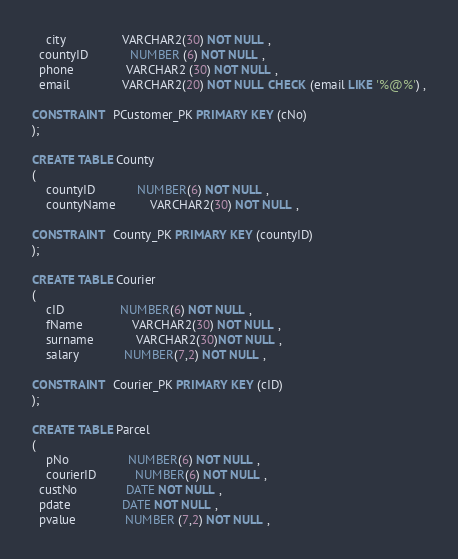<code> <loc_0><loc_0><loc_500><loc_500><_SQL_>	city                VARCHAR2(30) NOT NULL ,
  countyID            NUMBER (6) NOT NULL ,
  phone               VARCHAR2 (30) NOT NULL ,
  email               VARCHAR2(20) NOT NULL CHECK (email LIKE '%@%') ,
  
CONSTRAINT  PCustomer_PK PRIMARY KEY (cNo)
);

CREATE TABLE County
(
	countyID            NUMBER(6) NOT NULL ,
	countyName          VARCHAR2(30) NOT NULL ,
  
CONSTRAINT  County_PK PRIMARY KEY (countyID)
);

CREATE TABLE Courier
(
	cID                NUMBER(6) NOT NULL ,
	fName              VARCHAR2(30) NOT NULL ,
	surname            VARCHAR2(30)NOT NULL ,
	salary             NUMBER(7,2) NOT NULL ,
  
CONSTRAINT  Courier_PK PRIMARY KEY (cID)
);

CREATE TABLE Parcel
(
	pNo                 NUMBER(6) NOT NULL ,
	courierID           NUMBER(6) NOT NULL ,
  custNo              DATE NOT NULL ,
  pdate               DATE NOT NULL ,
  pvalue              NUMBER (7,2) NOT NULL ,</code> 